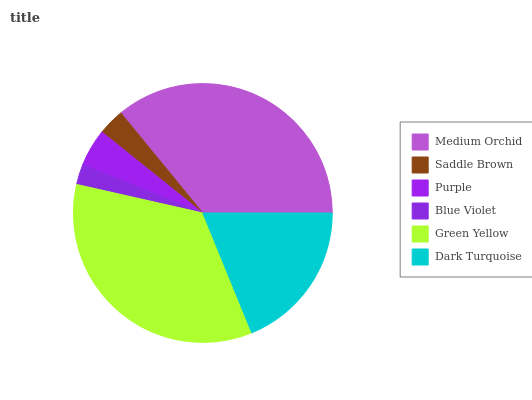Is Blue Violet the minimum?
Answer yes or no. Yes. Is Medium Orchid the maximum?
Answer yes or no. Yes. Is Saddle Brown the minimum?
Answer yes or no. No. Is Saddle Brown the maximum?
Answer yes or no. No. Is Medium Orchid greater than Saddle Brown?
Answer yes or no. Yes. Is Saddle Brown less than Medium Orchid?
Answer yes or no. Yes. Is Saddle Brown greater than Medium Orchid?
Answer yes or no. No. Is Medium Orchid less than Saddle Brown?
Answer yes or no. No. Is Dark Turquoise the high median?
Answer yes or no. Yes. Is Purple the low median?
Answer yes or no. Yes. Is Medium Orchid the high median?
Answer yes or no. No. Is Green Yellow the low median?
Answer yes or no. No. 